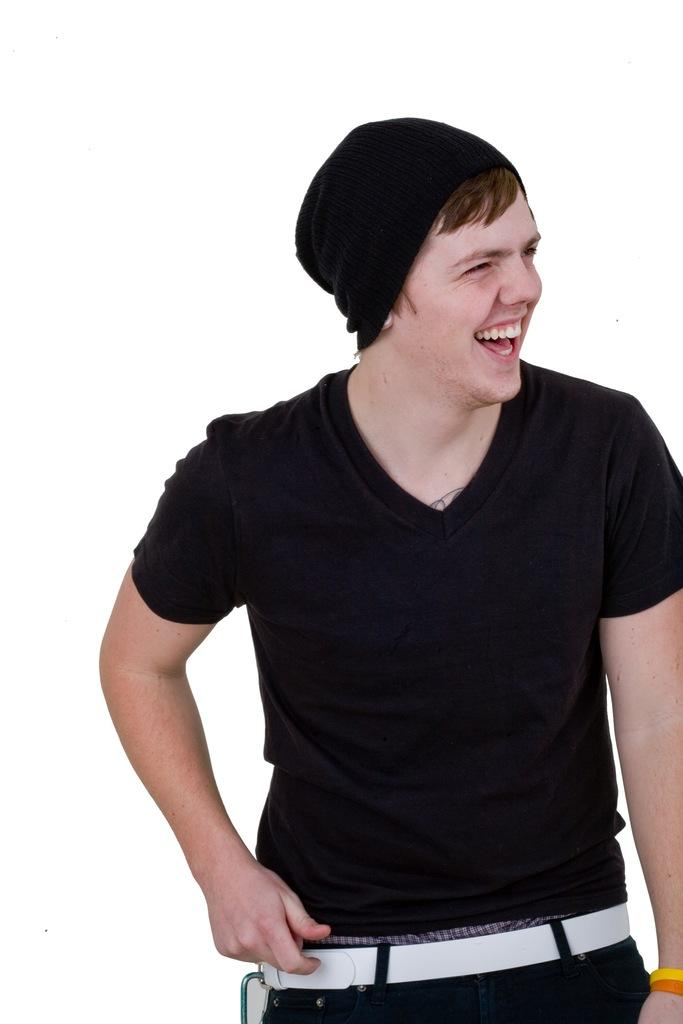Who is present in the image? There is a man in the image. What is the man wearing on his head? The man is wearing a cap. What accessory is the man wearing around his waist? The man is wearing a belt. What is the man's posture in the image? The man is standing. What is the man's facial expression in the image? The man is smiling. What color is the background of the image? The background of the image is white. How many shoes does the man have in his pocket in the image? There is no mention of shoes or pockets in the image, so it cannot be determined how many shoes the man has in his pocket. 